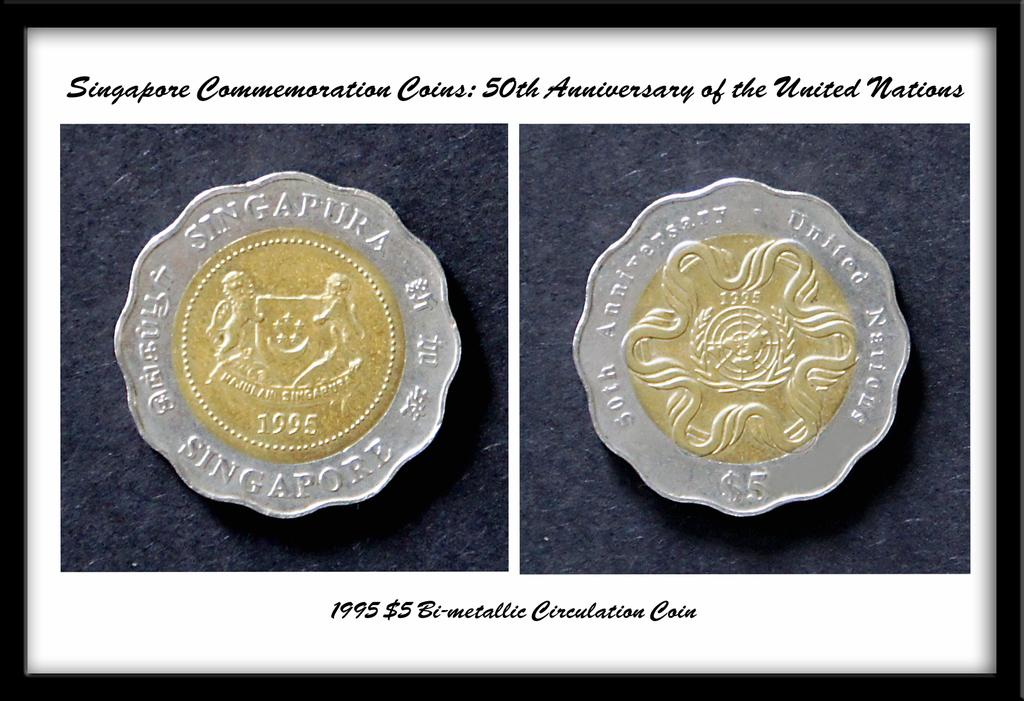Provide a one-sentence caption for the provided image. Picture showing a coin with the words "singapura" on top. 